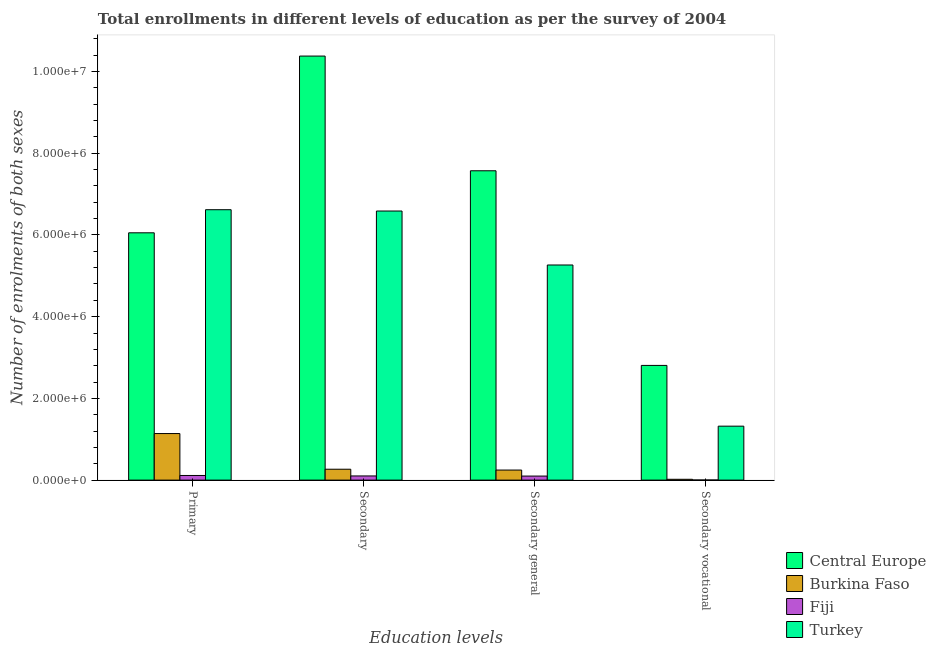What is the label of the 4th group of bars from the left?
Make the answer very short. Secondary vocational. What is the number of enrolments in secondary general education in Burkina Faso?
Your answer should be compact. 2.46e+05. Across all countries, what is the maximum number of enrolments in primary education?
Offer a terse response. 6.62e+06. Across all countries, what is the minimum number of enrolments in secondary vocational education?
Make the answer very short. 2840. In which country was the number of enrolments in secondary general education maximum?
Your answer should be very brief. Central Europe. In which country was the number of enrolments in secondary education minimum?
Your answer should be very brief. Fiji. What is the total number of enrolments in secondary general education in the graph?
Offer a very short reply. 1.32e+07. What is the difference between the number of enrolments in secondary general education in Burkina Faso and that in Turkey?
Ensure brevity in your answer.  -5.02e+06. What is the difference between the number of enrolments in secondary vocational education in Burkina Faso and the number of enrolments in secondary general education in Central Europe?
Provide a short and direct response. -7.55e+06. What is the average number of enrolments in primary education per country?
Your answer should be very brief. 3.48e+06. What is the difference between the number of enrolments in secondary vocational education and number of enrolments in secondary general education in Turkey?
Give a very brief answer. -3.94e+06. What is the ratio of the number of enrolments in secondary general education in Turkey to that in Central Europe?
Give a very brief answer. 0.7. Is the number of enrolments in primary education in Turkey less than that in Central Europe?
Your response must be concise. No. What is the difference between the highest and the second highest number of enrolments in secondary general education?
Give a very brief answer. 2.31e+06. What is the difference between the highest and the lowest number of enrolments in secondary vocational education?
Ensure brevity in your answer.  2.80e+06. In how many countries, is the number of enrolments in primary education greater than the average number of enrolments in primary education taken over all countries?
Keep it short and to the point. 2. Is the sum of the number of enrolments in secondary vocational education in Turkey and Burkina Faso greater than the maximum number of enrolments in primary education across all countries?
Provide a short and direct response. No. Is it the case that in every country, the sum of the number of enrolments in secondary education and number of enrolments in secondary vocational education is greater than the sum of number of enrolments in primary education and number of enrolments in secondary general education?
Your response must be concise. No. What does the 4th bar from the left in Secondary represents?
Keep it short and to the point. Turkey. What is the difference between two consecutive major ticks on the Y-axis?
Provide a succinct answer. 2.00e+06. Does the graph contain any zero values?
Give a very brief answer. No. Does the graph contain grids?
Your answer should be very brief. No. What is the title of the graph?
Your answer should be compact. Total enrollments in different levels of education as per the survey of 2004. Does "Congo (Republic)" appear as one of the legend labels in the graph?
Keep it short and to the point. No. What is the label or title of the X-axis?
Provide a short and direct response. Education levels. What is the label or title of the Y-axis?
Your answer should be compact. Number of enrolments of both sexes. What is the Number of enrolments of both sexes of Central Europe in Primary?
Provide a short and direct response. 6.05e+06. What is the Number of enrolments of both sexes of Burkina Faso in Primary?
Keep it short and to the point. 1.14e+06. What is the Number of enrolments of both sexes in Fiji in Primary?
Give a very brief answer. 1.13e+05. What is the Number of enrolments of both sexes of Turkey in Primary?
Your answer should be very brief. 6.62e+06. What is the Number of enrolments of both sexes in Central Europe in Secondary?
Offer a very short reply. 1.04e+07. What is the Number of enrolments of both sexes in Burkina Faso in Secondary?
Your answer should be very brief. 2.67e+05. What is the Number of enrolments of both sexes in Fiji in Secondary?
Your answer should be compact. 1.02e+05. What is the Number of enrolments of both sexes in Turkey in Secondary?
Give a very brief answer. 6.59e+06. What is the Number of enrolments of both sexes in Central Europe in Secondary general?
Make the answer very short. 7.57e+06. What is the Number of enrolments of both sexes in Burkina Faso in Secondary general?
Ensure brevity in your answer.  2.46e+05. What is the Number of enrolments of both sexes in Fiji in Secondary general?
Provide a short and direct response. 9.92e+04. What is the Number of enrolments of both sexes in Turkey in Secondary general?
Keep it short and to the point. 5.27e+06. What is the Number of enrolments of both sexes of Central Europe in Secondary vocational?
Provide a short and direct response. 2.81e+06. What is the Number of enrolments of both sexes in Burkina Faso in Secondary vocational?
Make the answer very short. 2.04e+04. What is the Number of enrolments of both sexes of Fiji in Secondary vocational?
Give a very brief answer. 2840. What is the Number of enrolments of both sexes of Turkey in Secondary vocational?
Your answer should be very brief. 1.32e+06. Across all Education levels, what is the maximum Number of enrolments of both sexes of Central Europe?
Provide a succinct answer. 1.04e+07. Across all Education levels, what is the maximum Number of enrolments of both sexes in Burkina Faso?
Make the answer very short. 1.14e+06. Across all Education levels, what is the maximum Number of enrolments of both sexes in Fiji?
Ensure brevity in your answer.  1.13e+05. Across all Education levels, what is the maximum Number of enrolments of both sexes of Turkey?
Keep it short and to the point. 6.62e+06. Across all Education levels, what is the minimum Number of enrolments of both sexes of Central Europe?
Offer a terse response. 2.81e+06. Across all Education levels, what is the minimum Number of enrolments of both sexes in Burkina Faso?
Ensure brevity in your answer.  2.04e+04. Across all Education levels, what is the minimum Number of enrolments of both sexes in Fiji?
Offer a terse response. 2840. Across all Education levels, what is the minimum Number of enrolments of both sexes of Turkey?
Give a very brief answer. 1.32e+06. What is the total Number of enrolments of both sexes in Central Europe in the graph?
Your answer should be very brief. 2.68e+07. What is the total Number of enrolments of both sexes in Burkina Faso in the graph?
Provide a succinct answer. 1.67e+06. What is the total Number of enrolments of both sexes in Fiji in the graph?
Give a very brief answer. 3.17e+05. What is the total Number of enrolments of both sexes of Turkey in the graph?
Offer a very short reply. 1.98e+07. What is the difference between the Number of enrolments of both sexes of Central Europe in Primary and that in Secondary?
Offer a very short reply. -4.33e+06. What is the difference between the Number of enrolments of both sexes in Burkina Faso in Primary and that in Secondary?
Offer a terse response. 8.73e+05. What is the difference between the Number of enrolments of both sexes of Fiji in Primary and that in Secondary?
Keep it short and to the point. 1.14e+04. What is the difference between the Number of enrolments of both sexes in Turkey in Primary and that in Secondary?
Ensure brevity in your answer.  3.24e+04. What is the difference between the Number of enrolments of both sexes of Central Europe in Primary and that in Secondary general?
Provide a short and direct response. -1.52e+06. What is the difference between the Number of enrolments of both sexes in Burkina Faso in Primary and that in Secondary general?
Make the answer very short. 8.93e+05. What is the difference between the Number of enrolments of both sexes in Fiji in Primary and that in Secondary general?
Give a very brief answer. 1.43e+04. What is the difference between the Number of enrolments of both sexes of Turkey in Primary and that in Secondary general?
Your answer should be very brief. 1.35e+06. What is the difference between the Number of enrolments of both sexes of Central Europe in Primary and that in Secondary vocational?
Offer a terse response. 3.25e+06. What is the difference between the Number of enrolments of both sexes in Burkina Faso in Primary and that in Secondary vocational?
Provide a succinct answer. 1.12e+06. What is the difference between the Number of enrolments of both sexes of Fiji in Primary and that in Secondary vocational?
Offer a very short reply. 1.11e+05. What is the difference between the Number of enrolments of both sexes in Turkey in Primary and that in Secondary vocational?
Your response must be concise. 5.30e+06. What is the difference between the Number of enrolments of both sexes of Central Europe in Secondary and that in Secondary general?
Provide a succinct answer. 2.81e+06. What is the difference between the Number of enrolments of both sexes of Burkina Faso in Secondary and that in Secondary general?
Provide a succinct answer. 2.04e+04. What is the difference between the Number of enrolments of both sexes of Fiji in Secondary and that in Secondary general?
Your response must be concise. 2840. What is the difference between the Number of enrolments of both sexes in Turkey in Secondary and that in Secondary general?
Offer a terse response. 1.32e+06. What is the difference between the Number of enrolments of both sexes in Central Europe in Secondary and that in Secondary vocational?
Keep it short and to the point. 7.57e+06. What is the difference between the Number of enrolments of both sexes of Burkina Faso in Secondary and that in Secondary vocational?
Offer a very short reply. 2.46e+05. What is the difference between the Number of enrolments of both sexes in Fiji in Secondary and that in Secondary vocational?
Your answer should be very brief. 9.92e+04. What is the difference between the Number of enrolments of both sexes of Turkey in Secondary and that in Secondary vocational?
Keep it short and to the point. 5.27e+06. What is the difference between the Number of enrolments of both sexes of Central Europe in Secondary general and that in Secondary vocational?
Provide a succinct answer. 4.76e+06. What is the difference between the Number of enrolments of both sexes of Burkina Faso in Secondary general and that in Secondary vocational?
Give a very brief answer. 2.26e+05. What is the difference between the Number of enrolments of both sexes of Fiji in Secondary general and that in Secondary vocational?
Your response must be concise. 9.63e+04. What is the difference between the Number of enrolments of both sexes of Turkey in Secondary general and that in Secondary vocational?
Make the answer very short. 3.94e+06. What is the difference between the Number of enrolments of both sexes of Central Europe in Primary and the Number of enrolments of both sexes of Burkina Faso in Secondary?
Offer a terse response. 5.79e+06. What is the difference between the Number of enrolments of both sexes in Central Europe in Primary and the Number of enrolments of both sexes in Fiji in Secondary?
Give a very brief answer. 5.95e+06. What is the difference between the Number of enrolments of both sexes in Central Europe in Primary and the Number of enrolments of both sexes in Turkey in Secondary?
Provide a succinct answer. -5.33e+05. What is the difference between the Number of enrolments of both sexes in Burkina Faso in Primary and the Number of enrolments of both sexes in Fiji in Secondary?
Provide a short and direct response. 1.04e+06. What is the difference between the Number of enrolments of both sexes in Burkina Faso in Primary and the Number of enrolments of both sexes in Turkey in Secondary?
Your answer should be compact. -5.45e+06. What is the difference between the Number of enrolments of both sexes in Fiji in Primary and the Number of enrolments of both sexes in Turkey in Secondary?
Your response must be concise. -6.47e+06. What is the difference between the Number of enrolments of both sexes in Central Europe in Primary and the Number of enrolments of both sexes in Burkina Faso in Secondary general?
Your answer should be very brief. 5.81e+06. What is the difference between the Number of enrolments of both sexes in Central Europe in Primary and the Number of enrolments of both sexes in Fiji in Secondary general?
Offer a very short reply. 5.95e+06. What is the difference between the Number of enrolments of both sexes of Central Europe in Primary and the Number of enrolments of both sexes of Turkey in Secondary general?
Give a very brief answer. 7.88e+05. What is the difference between the Number of enrolments of both sexes of Burkina Faso in Primary and the Number of enrolments of both sexes of Fiji in Secondary general?
Provide a short and direct response. 1.04e+06. What is the difference between the Number of enrolments of both sexes of Burkina Faso in Primary and the Number of enrolments of both sexes of Turkey in Secondary general?
Provide a succinct answer. -4.13e+06. What is the difference between the Number of enrolments of both sexes in Fiji in Primary and the Number of enrolments of both sexes in Turkey in Secondary general?
Give a very brief answer. -5.15e+06. What is the difference between the Number of enrolments of both sexes of Central Europe in Primary and the Number of enrolments of both sexes of Burkina Faso in Secondary vocational?
Your answer should be compact. 6.03e+06. What is the difference between the Number of enrolments of both sexes in Central Europe in Primary and the Number of enrolments of both sexes in Fiji in Secondary vocational?
Your answer should be compact. 6.05e+06. What is the difference between the Number of enrolments of both sexes in Central Europe in Primary and the Number of enrolments of both sexes in Turkey in Secondary vocational?
Offer a terse response. 4.73e+06. What is the difference between the Number of enrolments of both sexes of Burkina Faso in Primary and the Number of enrolments of both sexes of Fiji in Secondary vocational?
Your response must be concise. 1.14e+06. What is the difference between the Number of enrolments of both sexes of Burkina Faso in Primary and the Number of enrolments of both sexes of Turkey in Secondary vocational?
Provide a succinct answer. -1.81e+05. What is the difference between the Number of enrolments of both sexes in Fiji in Primary and the Number of enrolments of both sexes in Turkey in Secondary vocational?
Your answer should be very brief. -1.21e+06. What is the difference between the Number of enrolments of both sexes of Central Europe in Secondary and the Number of enrolments of both sexes of Burkina Faso in Secondary general?
Offer a very short reply. 1.01e+07. What is the difference between the Number of enrolments of both sexes of Central Europe in Secondary and the Number of enrolments of both sexes of Fiji in Secondary general?
Provide a succinct answer. 1.03e+07. What is the difference between the Number of enrolments of both sexes of Central Europe in Secondary and the Number of enrolments of both sexes of Turkey in Secondary general?
Ensure brevity in your answer.  5.11e+06. What is the difference between the Number of enrolments of both sexes in Burkina Faso in Secondary and the Number of enrolments of both sexes in Fiji in Secondary general?
Your answer should be very brief. 1.67e+05. What is the difference between the Number of enrolments of both sexes of Burkina Faso in Secondary and the Number of enrolments of both sexes of Turkey in Secondary general?
Offer a very short reply. -5.00e+06. What is the difference between the Number of enrolments of both sexes of Fiji in Secondary and the Number of enrolments of both sexes of Turkey in Secondary general?
Your answer should be compact. -5.16e+06. What is the difference between the Number of enrolments of both sexes of Central Europe in Secondary and the Number of enrolments of both sexes of Burkina Faso in Secondary vocational?
Your answer should be very brief. 1.04e+07. What is the difference between the Number of enrolments of both sexes of Central Europe in Secondary and the Number of enrolments of both sexes of Fiji in Secondary vocational?
Offer a terse response. 1.04e+07. What is the difference between the Number of enrolments of both sexes in Central Europe in Secondary and the Number of enrolments of both sexes in Turkey in Secondary vocational?
Your answer should be compact. 9.06e+06. What is the difference between the Number of enrolments of both sexes of Burkina Faso in Secondary and the Number of enrolments of both sexes of Fiji in Secondary vocational?
Your answer should be very brief. 2.64e+05. What is the difference between the Number of enrolments of both sexes in Burkina Faso in Secondary and the Number of enrolments of both sexes in Turkey in Secondary vocational?
Make the answer very short. -1.05e+06. What is the difference between the Number of enrolments of both sexes in Fiji in Secondary and the Number of enrolments of both sexes in Turkey in Secondary vocational?
Give a very brief answer. -1.22e+06. What is the difference between the Number of enrolments of both sexes in Central Europe in Secondary general and the Number of enrolments of both sexes in Burkina Faso in Secondary vocational?
Provide a succinct answer. 7.55e+06. What is the difference between the Number of enrolments of both sexes in Central Europe in Secondary general and the Number of enrolments of both sexes in Fiji in Secondary vocational?
Offer a terse response. 7.57e+06. What is the difference between the Number of enrolments of both sexes of Central Europe in Secondary general and the Number of enrolments of both sexes of Turkey in Secondary vocational?
Make the answer very short. 6.25e+06. What is the difference between the Number of enrolments of both sexes in Burkina Faso in Secondary general and the Number of enrolments of both sexes in Fiji in Secondary vocational?
Your response must be concise. 2.43e+05. What is the difference between the Number of enrolments of both sexes in Burkina Faso in Secondary general and the Number of enrolments of both sexes in Turkey in Secondary vocational?
Make the answer very short. -1.07e+06. What is the difference between the Number of enrolments of both sexes of Fiji in Secondary general and the Number of enrolments of both sexes of Turkey in Secondary vocational?
Provide a succinct answer. -1.22e+06. What is the average Number of enrolments of both sexes of Central Europe per Education levels?
Offer a very short reply. 6.70e+06. What is the average Number of enrolments of both sexes in Burkina Faso per Education levels?
Provide a succinct answer. 4.18e+05. What is the average Number of enrolments of both sexes of Fiji per Education levels?
Keep it short and to the point. 7.94e+04. What is the average Number of enrolments of both sexes in Turkey per Education levels?
Your answer should be very brief. 4.95e+06. What is the difference between the Number of enrolments of both sexes of Central Europe and Number of enrolments of both sexes of Burkina Faso in Primary?
Provide a succinct answer. 4.91e+06. What is the difference between the Number of enrolments of both sexes in Central Europe and Number of enrolments of both sexes in Fiji in Primary?
Make the answer very short. 5.94e+06. What is the difference between the Number of enrolments of both sexes of Central Europe and Number of enrolments of both sexes of Turkey in Primary?
Provide a succinct answer. -5.65e+05. What is the difference between the Number of enrolments of both sexes in Burkina Faso and Number of enrolments of both sexes in Fiji in Primary?
Your answer should be very brief. 1.03e+06. What is the difference between the Number of enrolments of both sexes in Burkina Faso and Number of enrolments of both sexes in Turkey in Primary?
Keep it short and to the point. -5.48e+06. What is the difference between the Number of enrolments of both sexes of Fiji and Number of enrolments of both sexes of Turkey in Primary?
Your answer should be compact. -6.50e+06. What is the difference between the Number of enrolments of both sexes of Central Europe and Number of enrolments of both sexes of Burkina Faso in Secondary?
Offer a very short reply. 1.01e+07. What is the difference between the Number of enrolments of both sexes in Central Europe and Number of enrolments of both sexes in Fiji in Secondary?
Your answer should be very brief. 1.03e+07. What is the difference between the Number of enrolments of both sexes of Central Europe and Number of enrolments of both sexes of Turkey in Secondary?
Provide a succinct answer. 3.79e+06. What is the difference between the Number of enrolments of both sexes in Burkina Faso and Number of enrolments of both sexes in Fiji in Secondary?
Ensure brevity in your answer.  1.65e+05. What is the difference between the Number of enrolments of both sexes in Burkina Faso and Number of enrolments of both sexes in Turkey in Secondary?
Keep it short and to the point. -6.32e+06. What is the difference between the Number of enrolments of both sexes in Fiji and Number of enrolments of both sexes in Turkey in Secondary?
Provide a short and direct response. -6.48e+06. What is the difference between the Number of enrolments of both sexes of Central Europe and Number of enrolments of both sexes of Burkina Faso in Secondary general?
Your answer should be very brief. 7.32e+06. What is the difference between the Number of enrolments of both sexes in Central Europe and Number of enrolments of both sexes in Fiji in Secondary general?
Your answer should be very brief. 7.47e+06. What is the difference between the Number of enrolments of both sexes in Central Europe and Number of enrolments of both sexes in Turkey in Secondary general?
Offer a terse response. 2.31e+06. What is the difference between the Number of enrolments of both sexes in Burkina Faso and Number of enrolments of both sexes in Fiji in Secondary general?
Provide a short and direct response. 1.47e+05. What is the difference between the Number of enrolments of both sexes of Burkina Faso and Number of enrolments of both sexes of Turkey in Secondary general?
Your response must be concise. -5.02e+06. What is the difference between the Number of enrolments of both sexes in Fiji and Number of enrolments of both sexes in Turkey in Secondary general?
Your answer should be compact. -5.17e+06. What is the difference between the Number of enrolments of both sexes of Central Europe and Number of enrolments of both sexes of Burkina Faso in Secondary vocational?
Your answer should be very brief. 2.79e+06. What is the difference between the Number of enrolments of both sexes in Central Europe and Number of enrolments of both sexes in Fiji in Secondary vocational?
Your answer should be compact. 2.80e+06. What is the difference between the Number of enrolments of both sexes in Central Europe and Number of enrolments of both sexes in Turkey in Secondary vocational?
Your response must be concise. 1.49e+06. What is the difference between the Number of enrolments of both sexes of Burkina Faso and Number of enrolments of both sexes of Fiji in Secondary vocational?
Your response must be concise. 1.75e+04. What is the difference between the Number of enrolments of both sexes of Burkina Faso and Number of enrolments of both sexes of Turkey in Secondary vocational?
Your response must be concise. -1.30e+06. What is the difference between the Number of enrolments of both sexes of Fiji and Number of enrolments of both sexes of Turkey in Secondary vocational?
Your response must be concise. -1.32e+06. What is the ratio of the Number of enrolments of both sexes of Central Europe in Primary to that in Secondary?
Keep it short and to the point. 0.58. What is the ratio of the Number of enrolments of both sexes in Burkina Faso in Primary to that in Secondary?
Your answer should be very brief. 4.28. What is the ratio of the Number of enrolments of both sexes of Fiji in Primary to that in Secondary?
Your answer should be very brief. 1.11. What is the ratio of the Number of enrolments of both sexes in Central Europe in Primary to that in Secondary general?
Your answer should be compact. 0.8. What is the ratio of the Number of enrolments of both sexes of Burkina Faso in Primary to that in Secondary general?
Ensure brevity in your answer.  4.63. What is the ratio of the Number of enrolments of both sexes of Fiji in Primary to that in Secondary general?
Make the answer very short. 1.14. What is the ratio of the Number of enrolments of both sexes in Turkey in Primary to that in Secondary general?
Keep it short and to the point. 1.26. What is the ratio of the Number of enrolments of both sexes in Central Europe in Primary to that in Secondary vocational?
Make the answer very short. 2.16. What is the ratio of the Number of enrolments of both sexes in Burkina Faso in Primary to that in Secondary vocational?
Provide a short and direct response. 55.92. What is the ratio of the Number of enrolments of both sexes of Fiji in Primary to that in Secondary vocational?
Ensure brevity in your answer.  39.95. What is the ratio of the Number of enrolments of both sexes in Turkey in Primary to that in Secondary vocational?
Your answer should be very brief. 5.01. What is the ratio of the Number of enrolments of both sexes of Central Europe in Secondary to that in Secondary general?
Keep it short and to the point. 1.37. What is the ratio of the Number of enrolments of both sexes in Burkina Faso in Secondary to that in Secondary general?
Make the answer very short. 1.08. What is the ratio of the Number of enrolments of both sexes in Fiji in Secondary to that in Secondary general?
Keep it short and to the point. 1.03. What is the ratio of the Number of enrolments of both sexes of Turkey in Secondary to that in Secondary general?
Offer a terse response. 1.25. What is the ratio of the Number of enrolments of both sexes in Central Europe in Secondary to that in Secondary vocational?
Your answer should be compact. 3.7. What is the ratio of the Number of enrolments of both sexes of Burkina Faso in Secondary to that in Secondary vocational?
Offer a terse response. 13.08. What is the ratio of the Number of enrolments of both sexes of Fiji in Secondary to that in Secondary vocational?
Offer a terse response. 35.92. What is the ratio of the Number of enrolments of both sexes in Turkey in Secondary to that in Secondary vocational?
Make the answer very short. 4.99. What is the ratio of the Number of enrolments of both sexes in Central Europe in Secondary general to that in Secondary vocational?
Ensure brevity in your answer.  2.7. What is the ratio of the Number of enrolments of both sexes in Burkina Faso in Secondary general to that in Secondary vocational?
Offer a very short reply. 12.08. What is the ratio of the Number of enrolments of both sexes of Fiji in Secondary general to that in Secondary vocational?
Make the answer very short. 34.92. What is the ratio of the Number of enrolments of both sexes of Turkey in Secondary general to that in Secondary vocational?
Offer a terse response. 3.99. What is the difference between the highest and the second highest Number of enrolments of both sexes in Central Europe?
Offer a very short reply. 2.81e+06. What is the difference between the highest and the second highest Number of enrolments of both sexes of Burkina Faso?
Make the answer very short. 8.73e+05. What is the difference between the highest and the second highest Number of enrolments of both sexes of Fiji?
Offer a very short reply. 1.14e+04. What is the difference between the highest and the second highest Number of enrolments of both sexes of Turkey?
Provide a short and direct response. 3.24e+04. What is the difference between the highest and the lowest Number of enrolments of both sexes of Central Europe?
Ensure brevity in your answer.  7.57e+06. What is the difference between the highest and the lowest Number of enrolments of both sexes of Burkina Faso?
Offer a terse response. 1.12e+06. What is the difference between the highest and the lowest Number of enrolments of both sexes of Fiji?
Provide a succinct answer. 1.11e+05. What is the difference between the highest and the lowest Number of enrolments of both sexes in Turkey?
Provide a short and direct response. 5.30e+06. 